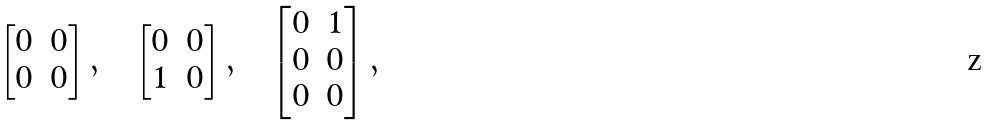Convert formula to latex. <formula><loc_0><loc_0><loc_500><loc_500>\begin{bmatrix} 0 & 0 \\ 0 & 0 \end{bmatrix} , \quad \begin{bmatrix} 0 & 0 \\ 1 & 0 \end{bmatrix} , \quad \begin{bmatrix} 0 & 1 \\ 0 & 0 \\ 0 & 0 \end{bmatrix} ,</formula> 